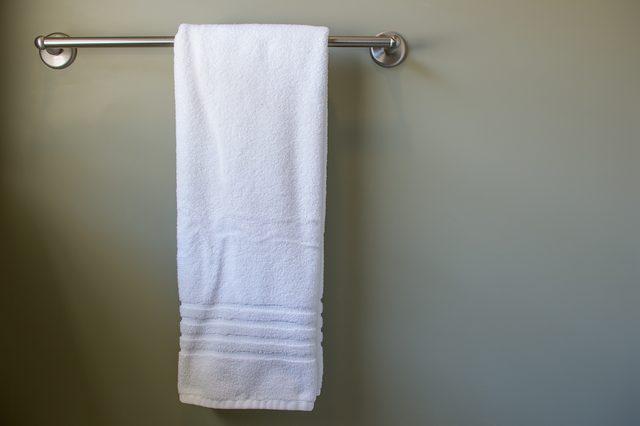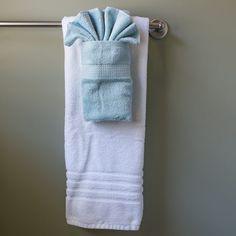The first image is the image on the left, the second image is the image on the right. Considering the images on both sides, is "In the left image, we see one white towel, on a rack." valid? Answer yes or no. Yes. The first image is the image on the left, the second image is the image on the right. Analyze the images presented: Is the assertion "In one image, the small hand towel is light blue and the larger bath towel behind it is white." valid? Answer yes or no. Yes. 